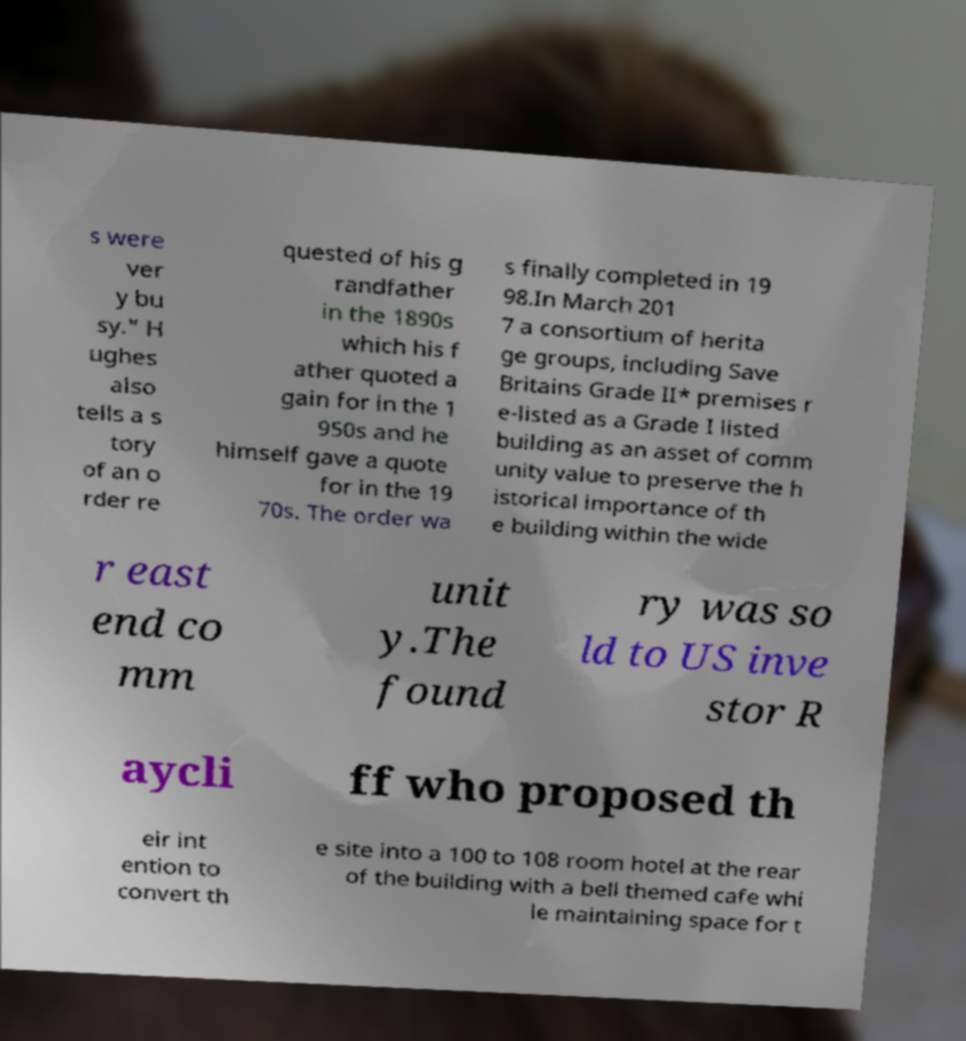Can you accurately transcribe the text from the provided image for me? s were ver y bu sy." H ughes also tells a s tory of an o rder re quested of his g randfather in the 1890s which his f ather quoted a gain for in the 1 950s and he himself gave a quote for in the 19 70s. The order wa s finally completed in 19 98.In March 201 7 a consortium of herita ge groups, including Save Britains Grade II* premises r e-listed as a Grade I listed building as an asset of comm unity value to preserve the h istorical importance of th e building within the wide r east end co mm unit y.The found ry was so ld to US inve stor R aycli ff who proposed th eir int ention to convert th e site into a 100 to 108 room hotel at the rear of the building with a bell themed cafe whi le maintaining space for t 